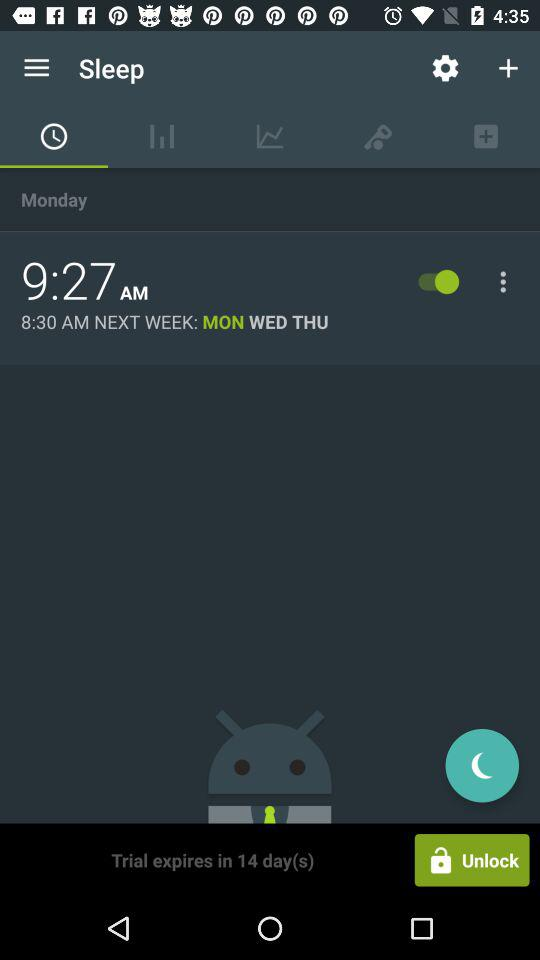In how many days will the trial expire? The trial will expire in 14 days. 